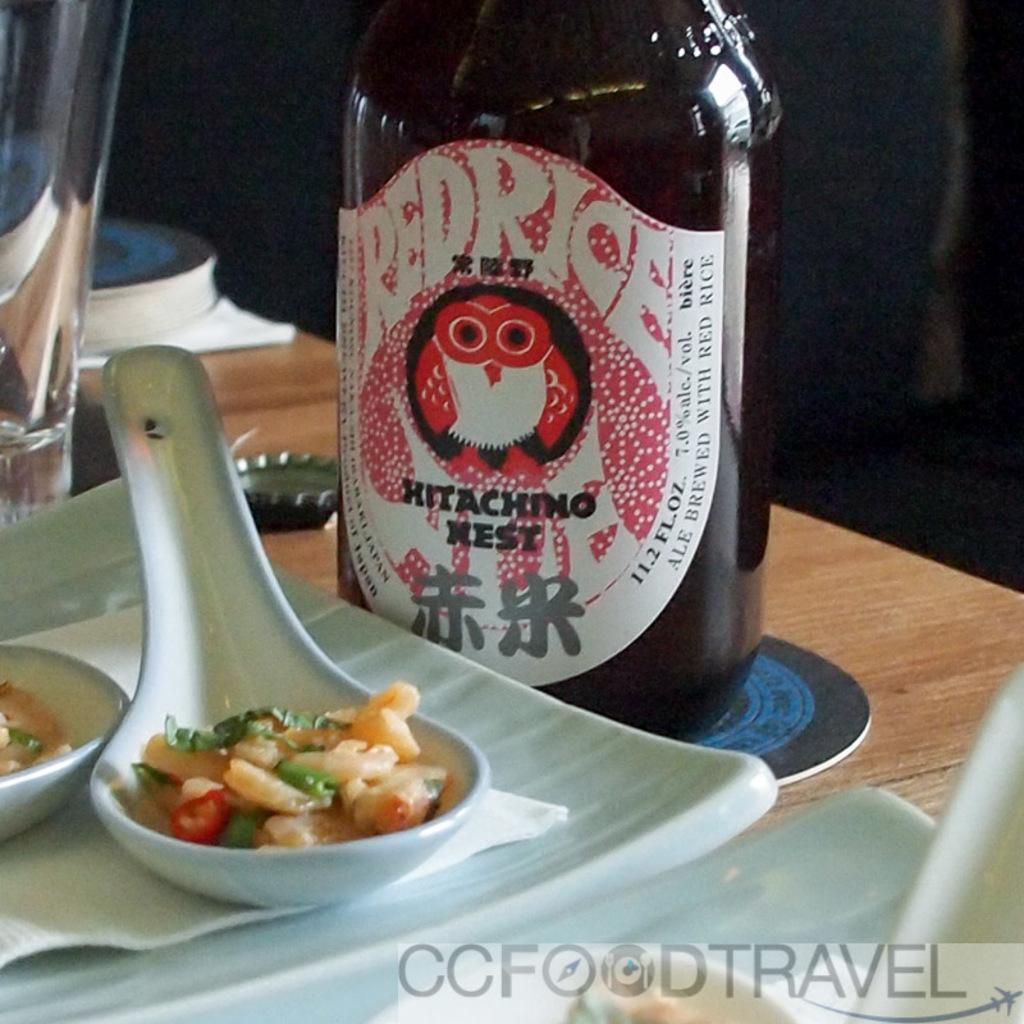<image>
Give a short and clear explanation of the subsequent image. a bottle of redrice hitachino nest sitting next to a spoonful of food 